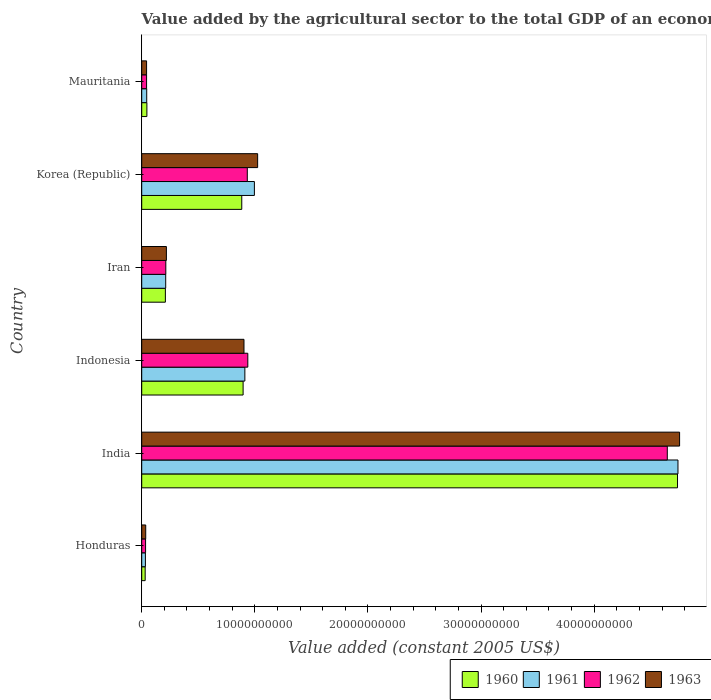How many different coloured bars are there?
Keep it short and to the point. 4. How many groups of bars are there?
Your answer should be very brief. 6. Are the number of bars per tick equal to the number of legend labels?
Offer a terse response. Yes. Are the number of bars on each tick of the Y-axis equal?
Your answer should be very brief. Yes. What is the label of the 1st group of bars from the top?
Your answer should be compact. Mauritania. What is the value added by the agricultural sector in 1961 in India?
Give a very brief answer. 4.74e+1. Across all countries, what is the maximum value added by the agricultural sector in 1963?
Make the answer very short. 4.76e+1. Across all countries, what is the minimum value added by the agricultural sector in 1961?
Offer a very short reply. 3.25e+08. In which country was the value added by the agricultural sector in 1960 minimum?
Provide a short and direct response. Honduras. What is the total value added by the agricultural sector in 1960 in the graph?
Give a very brief answer. 6.80e+1. What is the difference between the value added by the agricultural sector in 1963 in Iran and that in Mauritania?
Your response must be concise. 1.75e+09. What is the difference between the value added by the agricultural sector in 1960 in India and the value added by the agricultural sector in 1961 in Iran?
Your answer should be very brief. 4.52e+1. What is the average value added by the agricultural sector in 1963 per country?
Make the answer very short. 1.16e+1. What is the difference between the value added by the agricultural sector in 1963 and value added by the agricultural sector in 1962 in Indonesia?
Your response must be concise. -3.39e+08. What is the ratio of the value added by the agricultural sector in 1962 in Honduras to that in Korea (Republic)?
Offer a terse response. 0.04. Is the value added by the agricultural sector in 1963 in Indonesia less than that in Mauritania?
Make the answer very short. No. What is the difference between the highest and the second highest value added by the agricultural sector in 1961?
Offer a very short reply. 3.74e+1. What is the difference between the highest and the lowest value added by the agricultural sector in 1962?
Your answer should be compact. 4.61e+1. Is the sum of the value added by the agricultural sector in 1962 in Korea (Republic) and Mauritania greater than the maximum value added by the agricultural sector in 1963 across all countries?
Make the answer very short. No. Is it the case that in every country, the sum of the value added by the agricultural sector in 1961 and value added by the agricultural sector in 1962 is greater than the sum of value added by the agricultural sector in 1963 and value added by the agricultural sector in 1960?
Ensure brevity in your answer.  No. What does the 3rd bar from the top in Honduras represents?
Your response must be concise. 1961. How many bars are there?
Offer a very short reply. 24. Does the graph contain grids?
Your answer should be very brief. No. What is the title of the graph?
Your response must be concise. Value added by the agricultural sector to the total GDP of an economy. What is the label or title of the X-axis?
Your response must be concise. Value added (constant 2005 US$). What is the Value added (constant 2005 US$) in 1960 in Honduras?
Make the answer very short. 3.05e+08. What is the Value added (constant 2005 US$) of 1961 in Honduras?
Your response must be concise. 3.25e+08. What is the Value added (constant 2005 US$) of 1962 in Honduras?
Your answer should be compact. 3.41e+08. What is the Value added (constant 2005 US$) of 1963 in Honduras?
Your answer should be compact. 3.53e+08. What is the Value added (constant 2005 US$) of 1960 in India?
Provide a succinct answer. 4.74e+1. What is the Value added (constant 2005 US$) of 1961 in India?
Offer a very short reply. 4.74e+1. What is the Value added (constant 2005 US$) of 1962 in India?
Ensure brevity in your answer.  4.65e+1. What is the Value added (constant 2005 US$) in 1963 in India?
Ensure brevity in your answer.  4.76e+1. What is the Value added (constant 2005 US$) in 1960 in Indonesia?
Ensure brevity in your answer.  8.96e+09. What is the Value added (constant 2005 US$) of 1961 in Indonesia?
Your answer should be very brief. 9.12e+09. What is the Value added (constant 2005 US$) in 1962 in Indonesia?
Offer a very short reply. 9.38e+09. What is the Value added (constant 2005 US$) in 1963 in Indonesia?
Make the answer very short. 9.04e+09. What is the Value added (constant 2005 US$) in 1960 in Iran?
Ensure brevity in your answer.  2.09e+09. What is the Value added (constant 2005 US$) in 1961 in Iran?
Offer a very short reply. 2.12e+09. What is the Value added (constant 2005 US$) of 1962 in Iran?
Keep it short and to the point. 2.13e+09. What is the Value added (constant 2005 US$) in 1963 in Iran?
Provide a succinct answer. 2.18e+09. What is the Value added (constant 2005 US$) of 1960 in Korea (Republic)?
Keep it short and to the point. 8.84e+09. What is the Value added (constant 2005 US$) of 1961 in Korea (Republic)?
Offer a terse response. 9.96e+09. What is the Value added (constant 2005 US$) of 1962 in Korea (Republic)?
Give a very brief answer. 9.33e+09. What is the Value added (constant 2005 US$) in 1963 in Korea (Republic)?
Make the answer very short. 1.02e+1. What is the Value added (constant 2005 US$) of 1960 in Mauritania?
Provide a short and direct response. 4.57e+08. What is the Value added (constant 2005 US$) in 1961 in Mauritania?
Offer a very short reply. 4.42e+08. What is the Value added (constant 2005 US$) of 1962 in Mauritania?
Make the answer very short. 4.29e+08. What is the Value added (constant 2005 US$) of 1963 in Mauritania?
Offer a terse response. 4.30e+08. Across all countries, what is the maximum Value added (constant 2005 US$) in 1960?
Your response must be concise. 4.74e+1. Across all countries, what is the maximum Value added (constant 2005 US$) in 1961?
Offer a very short reply. 4.74e+1. Across all countries, what is the maximum Value added (constant 2005 US$) of 1962?
Provide a short and direct response. 4.65e+1. Across all countries, what is the maximum Value added (constant 2005 US$) in 1963?
Your answer should be compact. 4.76e+1. Across all countries, what is the minimum Value added (constant 2005 US$) in 1960?
Provide a short and direct response. 3.05e+08. Across all countries, what is the minimum Value added (constant 2005 US$) of 1961?
Offer a terse response. 3.25e+08. Across all countries, what is the minimum Value added (constant 2005 US$) in 1962?
Provide a succinct answer. 3.41e+08. Across all countries, what is the minimum Value added (constant 2005 US$) of 1963?
Give a very brief answer. 3.53e+08. What is the total Value added (constant 2005 US$) in 1960 in the graph?
Offer a very short reply. 6.80e+1. What is the total Value added (constant 2005 US$) in 1961 in the graph?
Offer a very short reply. 6.94e+1. What is the total Value added (constant 2005 US$) of 1962 in the graph?
Offer a terse response. 6.81e+1. What is the total Value added (constant 2005 US$) of 1963 in the graph?
Keep it short and to the point. 6.98e+1. What is the difference between the Value added (constant 2005 US$) of 1960 in Honduras and that in India?
Make the answer very short. -4.71e+1. What is the difference between the Value added (constant 2005 US$) in 1961 in Honduras and that in India?
Offer a terse response. -4.71e+1. What is the difference between the Value added (constant 2005 US$) of 1962 in Honduras and that in India?
Give a very brief answer. -4.61e+1. What is the difference between the Value added (constant 2005 US$) in 1963 in Honduras and that in India?
Provide a short and direct response. -4.72e+1. What is the difference between the Value added (constant 2005 US$) of 1960 in Honduras and that in Indonesia?
Give a very brief answer. -8.66e+09. What is the difference between the Value added (constant 2005 US$) in 1961 in Honduras and that in Indonesia?
Ensure brevity in your answer.  -8.79e+09. What is the difference between the Value added (constant 2005 US$) in 1962 in Honduras and that in Indonesia?
Your answer should be very brief. -9.04e+09. What is the difference between the Value added (constant 2005 US$) in 1963 in Honduras and that in Indonesia?
Offer a very short reply. -8.69e+09. What is the difference between the Value added (constant 2005 US$) in 1960 in Honduras and that in Iran?
Provide a short and direct response. -1.79e+09. What is the difference between the Value added (constant 2005 US$) of 1961 in Honduras and that in Iran?
Your answer should be compact. -1.79e+09. What is the difference between the Value added (constant 2005 US$) of 1962 in Honduras and that in Iran?
Your answer should be compact. -1.79e+09. What is the difference between the Value added (constant 2005 US$) of 1963 in Honduras and that in Iran?
Offer a very short reply. -1.83e+09. What is the difference between the Value added (constant 2005 US$) of 1960 in Honduras and that in Korea (Republic)?
Your answer should be compact. -8.54e+09. What is the difference between the Value added (constant 2005 US$) of 1961 in Honduras and that in Korea (Republic)?
Your answer should be compact. -9.64e+09. What is the difference between the Value added (constant 2005 US$) of 1962 in Honduras and that in Korea (Republic)?
Keep it short and to the point. -8.99e+09. What is the difference between the Value added (constant 2005 US$) in 1963 in Honduras and that in Korea (Republic)?
Ensure brevity in your answer.  -9.89e+09. What is the difference between the Value added (constant 2005 US$) in 1960 in Honduras and that in Mauritania?
Ensure brevity in your answer.  -1.51e+08. What is the difference between the Value added (constant 2005 US$) in 1961 in Honduras and that in Mauritania?
Offer a terse response. -1.17e+08. What is the difference between the Value added (constant 2005 US$) of 1962 in Honduras and that in Mauritania?
Your answer should be very brief. -8.84e+07. What is the difference between the Value added (constant 2005 US$) in 1963 in Honduras and that in Mauritania?
Your answer should be very brief. -7.67e+07. What is the difference between the Value added (constant 2005 US$) of 1960 in India and that in Indonesia?
Keep it short and to the point. 3.84e+1. What is the difference between the Value added (constant 2005 US$) in 1961 in India and that in Indonesia?
Your answer should be very brief. 3.83e+1. What is the difference between the Value added (constant 2005 US$) in 1962 in India and that in Indonesia?
Offer a very short reply. 3.71e+1. What is the difference between the Value added (constant 2005 US$) of 1963 in India and that in Indonesia?
Make the answer very short. 3.85e+1. What is the difference between the Value added (constant 2005 US$) of 1960 in India and that in Iran?
Your answer should be compact. 4.53e+1. What is the difference between the Value added (constant 2005 US$) of 1961 in India and that in Iran?
Keep it short and to the point. 4.53e+1. What is the difference between the Value added (constant 2005 US$) in 1962 in India and that in Iran?
Offer a terse response. 4.43e+1. What is the difference between the Value added (constant 2005 US$) in 1963 in India and that in Iran?
Give a very brief answer. 4.54e+1. What is the difference between the Value added (constant 2005 US$) of 1960 in India and that in Korea (Republic)?
Provide a short and direct response. 3.85e+1. What is the difference between the Value added (constant 2005 US$) of 1961 in India and that in Korea (Republic)?
Make the answer very short. 3.74e+1. What is the difference between the Value added (constant 2005 US$) in 1962 in India and that in Korea (Republic)?
Ensure brevity in your answer.  3.71e+1. What is the difference between the Value added (constant 2005 US$) of 1963 in India and that in Korea (Republic)?
Offer a very short reply. 3.73e+1. What is the difference between the Value added (constant 2005 US$) of 1960 in India and that in Mauritania?
Your response must be concise. 4.69e+1. What is the difference between the Value added (constant 2005 US$) of 1961 in India and that in Mauritania?
Your answer should be very brief. 4.70e+1. What is the difference between the Value added (constant 2005 US$) of 1962 in India and that in Mauritania?
Your answer should be compact. 4.60e+1. What is the difference between the Value added (constant 2005 US$) of 1963 in India and that in Mauritania?
Provide a short and direct response. 4.71e+1. What is the difference between the Value added (constant 2005 US$) in 1960 in Indonesia and that in Iran?
Your response must be concise. 6.87e+09. What is the difference between the Value added (constant 2005 US$) of 1961 in Indonesia and that in Iran?
Offer a terse response. 7.00e+09. What is the difference between the Value added (constant 2005 US$) of 1962 in Indonesia and that in Iran?
Ensure brevity in your answer.  7.25e+09. What is the difference between the Value added (constant 2005 US$) in 1963 in Indonesia and that in Iran?
Your answer should be very brief. 6.86e+09. What is the difference between the Value added (constant 2005 US$) in 1960 in Indonesia and that in Korea (Republic)?
Provide a succinct answer. 1.19e+08. What is the difference between the Value added (constant 2005 US$) of 1961 in Indonesia and that in Korea (Republic)?
Your answer should be very brief. -8.44e+08. What is the difference between the Value added (constant 2005 US$) in 1962 in Indonesia and that in Korea (Republic)?
Your response must be concise. 4.52e+07. What is the difference between the Value added (constant 2005 US$) of 1963 in Indonesia and that in Korea (Republic)?
Your response must be concise. -1.21e+09. What is the difference between the Value added (constant 2005 US$) of 1960 in Indonesia and that in Mauritania?
Your answer should be very brief. 8.51e+09. What is the difference between the Value added (constant 2005 US$) of 1961 in Indonesia and that in Mauritania?
Offer a very short reply. 8.68e+09. What is the difference between the Value added (constant 2005 US$) of 1962 in Indonesia and that in Mauritania?
Your response must be concise. 8.95e+09. What is the difference between the Value added (constant 2005 US$) in 1963 in Indonesia and that in Mauritania?
Your answer should be compact. 8.61e+09. What is the difference between the Value added (constant 2005 US$) of 1960 in Iran and that in Korea (Republic)?
Make the answer very short. -6.75e+09. What is the difference between the Value added (constant 2005 US$) in 1961 in Iran and that in Korea (Republic)?
Provide a succinct answer. -7.84e+09. What is the difference between the Value added (constant 2005 US$) in 1962 in Iran and that in Korea (Republic)?
Provide a succinct answer. -7.20e+09. What is the difference between the Value added (constant 2005 US$) of 1963 in Iran and that in Korea (Republic)?
Keep it short and to the point. -8.07e+09. What is the difference between the Value added (constant 2005 US$) in 1960 in Iran and that in Mauritania?
Make the answer very short. 1.63e+09. What is the difference between the Value added (constant 2005 US$) in 1961 in Iran and that in Mauritania?
Ensure brevity in your answer.  1.68e+09. What is the difference between the Value added (constant 2005 US$) of 1962 in Iran and that in Mauritania?
Ensure brevity in your answer.  1.70e+09. What is the difference between the Value added (constant 2005 US$) in 1963 in Iran and that in Mauritania?
Keep it short and to the point. 1.75e+09. What is the difference between the Value added (constant 2005 US$) of 1960 in Korea (Republic) and that in Mauritania?
Provide a succinct answer. 8.39e+09. What is the difference between the Value added (constant 2005 US$) of 1961 in Korea (Republic) and that in Mauritania?
Provide a short and direct response. 9.52e+09. What is the difference between the Value added (constant 2005 US$) in 1962 in Korea (Republic) and that in Mauritania?
Offer a terse response. 8.91e+09. What is the difference between the Value added (constant 2005 US$) of 1963 in Korea (Republic) and that in Mauritania?
Give a very brief answer. 9.82e+09. What is the difference between the Value added (constant 2005 US$) in 1960 in Honduras and the Value added (constant 2005 US$) in 1961 in India?
Offer a very short reply. -4.71e+1. What is the difference between the Value added (constant 2005 US$) in 1960 in Honduras and the Value added (constant 2005 US$) in 1962 in India?
Your answer should be compact. -4.62e+1. What is the difference between the Value added (constant 2005 US$) of 1960 in Honduras and the Value added (constant 2005 US$) of 1963 in India?
Your response must be concise. -4.72e+1. What is the difference between the Value added (constant 2005 US$) of 1961 in Honduras and the Value added (constant 2005 US$) of 1962 in India?
Give a very brief answer. -4.61e+1. What is the difference between the Value added (constant 2005 US$) in 1961 in Honduras and the Value added (constant 2005 US$) in 1963 in India?
Offer a very short reply. -4.72e+1. What is the difference between the Value added (constant 2005 US$) of 1962 in Honduras and the Value added (constant 2005 US$) of 1963 in India?
Your answer should be very brief. -4.72e+1. What is the difference between the Value added (constant 2005 US$) of 1960 in Honduras and the Value added (constant 2005 US$) of 1961 in Indonesia?
Your answer should be very brief. -8.81e+09. What is the difference between the Value added (constant 2005 US$) of 1960 in Honduras and the Value added (constant 2005 US$) of 1962 in Indonesia?
Your answer should be compact. -9.07e+09. What is the difference between the Value added (constant 2005 US$) of 1960 in Honduras and the Value added (constant 2005 US$) of 1963 in Indonesia?
Provide a short and direct response. -8.73e+09. What is the difference between the Value added (constant 2005 US$) of 1961 in Honduras and the Value added (constant 2005 US$) of 1962 in Indonesia?
Offer a terse response. -9.05e+09. What is the difference between the Value added (constant 2005 US$) of 1961 in Honduras and the Value added (constant 2005 US$) of 1963 in Indonesia?
Ensure brevity in your answer.  -8.72e+09. What is the difference between the Value added (constant 2005 US$) of 1962 in Honduras and the Value added (constant 2005 US$) of 1963 in Indonesia?
Make the answer very short. -8.70e+09. What is the difference between the Value added (constant 2005 US$) of 1960 in Honduras and the Value added (constant 2005 US$) of 1961 in Iran?
Offer a terse response. -1.81e+09. What is the difference between the Value added (constant 2005 US$) in 1960 in Honduras and the Value added (constant 2005 US$) in 1962 in Iran?
Ensure brevity in your answer.  -1.82e+09. What is the difference between the Value added (constant 2005 US$) of 1960 in Honduras and the Value added (constant 2005 US$) of 1963 in Iran?
Ensure brevity in your answer.  -1.88e+09. What is the difference between the Value added (constant 2005 US$) in 1961 in Honduras and the Value added (constant 2005 US$) in 1962 in Iran?
Offer a terse response. -1.80e+09. What is the difference between the Value added (constant 2005 US$) of 1961 in Honduras and the Value added (constant 2005 US$) of 1963 in Iran?
Give a very brief answer. -1.86e+09. What is the difference between the Value added (constant 2005 US$) of 1962 in Honduras and the Value added (constant 2005 US$) of 1963 in Iran?
Provide a succinct answer. -1.84e+09. What is the difference between the Value added (constant 2005 US$) in 1960 in Honduras and the Value added (constant 2005 US$) in 1961 in Korea (Republic)?
Offer a terse response. -9.66e+09. What is the difference between the Value added (constant 2005 US$) of 1960 in Honduras and the Value added (constant 2005 US$) of 1962 in Korea (Republic)?
Provide a short and direct response. -9.03e+09. What is the difference between the Value added (constant 2005 US$) in 1960 in Honduras and the Value added (constant 2005 US$) in 1963 in Korea (Republic)?
Provide a short and direct response. -9.94e+09. What is the difference between the Value added (constant 2005 US$) of 1961 in Honduras and the Value added (constant 2005 US$) of 1962 in Korea (Republic)?
Your response must be concise. -9.01e+09. What is the difference between the Value added (constant 2005 US$) of 1961 in Honduras and the Value added (constant 2005 US$) of 1963 in Korea (Republic)?
Make the answer very short. -9.92e+09. What is the difference between the Value added (constant 2005 US$) of 1962 in Honduras and the Value added (constant 2005 US$) of 1963 in Korea (Republic)?
Provide a short and direct response. -9.91e+09. What is the difference between the Value added (constant 2005 US$) in 1960 in Honduras and the Value added (constant 2005 US$) in 1961 in Mauritania?
Make the answer very short. -1.37e+08. What is the difference between the Value added (constant 2005 US$) in 1960 in Honduras and the Value added (constant 2005 US$) in 1962 in Mauritania?
Provide a succinct answer. -1.24e+08. What is the difference between the Value added (constant 2005 US$) of 1960 in Honduras and the Value added (constant 2005 US$) of 1963 in Mauritania?
Make the answer very short. -1.24e+08. What is the difference between the Value added (constant 2005 US$) of 1961 in Honduras and the Value added (constant 2005 US$) of 1962 in Mauritania?
Keep it short and to the point. -1.04e+08. What is the difference between the Value added (constant 2005 US$) of 1961 in Honduras and the Value added (constant 2005 US$) of 1963 in Mauritania?
Give a very brief answer. -1.05e+08. What is the difference between the Value added (constant 2005 US$) of 1962 in Honduras and the Value added (constant 2005 US$) of 1963 in Mauritania?
Provide a succinct answer. -8.91e+07. What is the difference between the Value added (constant 2005 US$) in 1960 in India and the Value added (constant 2005 US$) in 1961 in Indonesia?
Make the answer very short. 3.83e+1. What is the difference between the Value added (constant 2005 US$) in 1960 in India and the Value added (constant 2005 US$) in 1962 in Indonesia?
Your response must be concise. 3.80e+1. What is the difference between the Value added (constant 2005 US$) in 1960 in India and the Value added (constant 2005 US$) in 1963 in Indonesia?
Provide a succinct answer. 3.83e+1. What is the difference between the Value added (constant 2005 US$) of 1961 in India and the Value added (constant 2005 US$) of 1962 in Indonesia?
Your answer should be very brief. 3.80e+1. What is the difference between the Value added (constant 2005 US$) of 1961 in India and the Value added (constant 2005 US$) of 1963 in Indonesia?
Provide a succinct answer. 3.84e+1. What is the difference between the Value added (constant 2005 US$) in 1962 in India and the Value added (constant 2005 US$) in 1963 in Indonesia?
Offer a very short reply. 3.74e+1. What is the difference between the Value added (constant 2005 US$) of 1960 in India and the Value added (constant 2005 US$) of 1961 in Iran?
Offer a very short reply. 4.52e+1. What is the difference between the Value added (constant 2005 US$) in 1960 in India and the Value added (constant 2005 US$) in 1962 in Iran?
Give a very brief answer. 4.52e+1. What is the difference between the Value added (constant 2005 US$) of 1960 in India and the Value added (constant 2005 US$) of 1963 in Iran?
Keep it short and to the point. 4.52e+1. What is the difference between the Value added (constant 2005 US$) of 1961 in India and the Value added (constant 2005 US$) of 1962 in Iran?
Provide a succinct answer. 4.53e+1. What is the difference between the Value added (constant 2005 US$) in 1961 in India and the Value added (constant 2005 US$) in 1963 in Iran?
Offer a very short reply. 4.52e+1. What is the difference between the Value added (constant 2005 US$) in 1962 in India and the Value added (constant 2005 US$) in 1963 in Iran?
Ensure brevity in your answer.  4.43e+1. What is the difference between the Value added (constant 2005 US$) of 1960 in India and the Value added (constant 2005 US$) of 1961 in Korea (Republic)?
Keep it short and to the point. 3.74e+1. What is the difference between the Value added (constant 2005 US$) of 1960 in India and the Value added (constant 2005 US$) of 1962 in Korea (Republic)?
Your response must be concise. 3.80e+1. What is the difference between the Value added (constant 2005 US$) of 1960 in India and the Value added (constant 2005 US$) of 1963 in Korea (Republic)?
Ensure brevity in your answer.  3.71e+1. What is the difference between the Value added (constant 2005 US$) in 1961 in India and the Value added (constant 2005 US$) in 1962 in Korea (Republic)?
Give a very brief answer. 3.81e+1. What is the difference between the Value added (constant 2005 US$) of 1961 in India and the Value added (constant 2005 US$) of 1963 in Korea (Republic)?
Offer a very short reply. 3.72e+1. What is the difference between the Value added (constant 2005 US$) in 1962 in India and the Value added (constant 2005 US$) in 1963 in Korea (Republic)?
Offer a terse response. 3.62e+1. What is the difference between the Value added (constant 2005 US$) in 1960 in India and the Value added (constant 2005 US$) in 1961 in Mauritania?
Your answer should be very brief. 4.69e+1. What is the difference between the Value added (constant 2005 US$) in 1960 in India and the Value added (constant 2005 US$) in 1962 in Mauritania?
Your answer should be compact. 4.69e+1. What is the difference between the Value added (constant 2005 US$) in 1960 in India and the Value added (constant 2005 US$) in 1963 in Mauritania?
Your answer should be very brief. 4.69e+1. What is the difference between the Value added (constant 2005 US$) in 1961 in India and the Value added (constant 2005 US$) in 1962 in Mauritania?
Make the answer very short. 4.70e+1. What is the difference between the Value added (constant 2005 US$) in 1961 in India and the Value added (constant 2005 US$) in 1963 in Mauritania?
Keep it short and to the point. 4.70e+1. What is the difference between the Value added (constant 2005 US$) in 1962 in India and the Value added (constant 2005 US$) in 1963 in Mauritania?
Your response must be concise. 4.60e+1. What is the difference between the Value added (constant 2005 US$) in 1960 in Indonesia and the Value added (constant 2005 US$) in 1961 in Iran?
Your answer should be compact. 6.84e+09. What is the difference between the Value added (constant 2005 US$) in 1960 in Indonesia and the Value added (constant 2005 US$) in 1962 in Iran?
Offer a very short reply. 6.83e+09. What is the difference between the Value added (constant 2005 US$) in 1960 in Indonesia and the Value added (constant 2005 US$) in 1963 in Iran?
Offer a terse response. 6.78e+09. What is the difference between the Value added (constant 2005 US$) of 1961 in Indonesia and the Value added (constant 2005 US$) of 1962 in Iran?
Provide a succinct answer. 6.99e+09. What is the difference between the Value added (constant 2005 US$) of 1961 in Indonesia and the Value added (constant 2005 US$) of 1963 in Iran?
Offer a terse response. 6.94e+09. What is the difference between the Value added (constant 2005 US$) in 1962 in Indonesia and the Value added (constant 2005 US$) in 1963 in Iran?
Provide a succinct answer. 7.20e+09. What is the difference between the Value added (constant 2005 US$) in 1960 in Indonesia and the Value added (constant 2005 US$) in 1961 in Korea (Republic)?
Your answer should be very brief. -9.98e+08. What is the difference between the Value added (constant 2005 US$) of 1960 in Indonesia and the Value added (constant 2005 US$) of 1962 in Korea (Republic)?
Your response must be concise. -3.71e+08. What is the difference between the Value added (constant 2005 US$) of 1960 in Indonesia and the Value added (constant 2005 US$) of 1963 in Korea (Republic)?
Keep it short and to the point. -1.28e+09. What is the difference between the Value added (constant 2005 US$) in 1961 in Indonesia and the Value added (constant 2005 US$) in 1962 in Korea (Republic)?
Your answer should be very brief. -2.17e+08. What is the difference between the Value added (constant 2005 US$) of 1961 in Indonesia and the Value added (constant 2005 US$) of 1963 in Korea (Republic)?
Make the answer very short. -1.13e+09. What is the difference between the Value added (constant 2005 US$) of 1962 in Indonesia and the Value added (constant 2005 US$) of 1963 in Korea (Republic)?
Your response must be concise. -8.69e+08. What is the difference between the Value added (constant 2005 US$) in 1960 in Indonesia and the Value added (constant 2005 US$) in 1961 in Mauritania?
Keep it short and to the point. 8.52e+09. What is the difference between the Value added (constant 2005 US$) of 1960 in Indonesia and the Value added (constant 2005 US$) of 1962 in Mauritania?
Ensure brevity in your answer.  8.53e+09. What is the difference between the Value added (constant 2005 US$) of 1960 in Indonesia and the Value added (constant 2005 US$) of 1963 in Mauritania?
Offer a very short reply. 8.53e+09. What is the difference between the Value added (constant 2005 US$) in 1961 in Indonesia and the Value added (constant 2005 US$) in 1962 in Mauritania?
Your answer should be very brief. 8.69e+09. What is the difference between the Value added (constant 2005 US$) in 1961 in Indonesia and the Value added (constant 2005 US$) in 1963 in Mauritania?
Your answer should be very brief. 8.69e+09. What is the difference between the Value added (constant 2005 US$) in 1962 in Indonesia and the Value added (constant 2005 US$) in 1963 in Mauritania?
Your answer should be very brief. 8.95e+09. What is the difference between the Value added (constant 2005 US$) of 1960 in Iran and the Value added (constant 2005 US$) of 1961 in Korea (Republic)?
Provide a short and direct response. -7.87e+09. What is the difference between the Value added (constant 2005 US$) in 1960 in Iran and the Value added (constant 2005 US$) in 1962 in Korea (Republic)?
Make the answer very short. -7.24e+09. What is the difference between the Value added (constant 2005 US$) in 1960 in Iran and the Value added (constant 2005 US$) in 1963 in Korea (Republic)?
Your response must be concise. -8.16e+09. What is the difference between the Value added (constant 2005 US$) in 1961 in Iran and the Value added (constant 2005 US$) in 1962 in Korea (Republic)?
Provide a succinct answer. -7.21e+09. What is the difference between the Value added (constant 2005 US$) in 1961 in Iran and the Value added (constant 2005 US$) in 1963 in Korea (Republic)?
Offer a very short reply. -8.13e+09. What is the difference between the Value added (constant 2005 US$) of 1962 in Iran and the Value added (constant 2005 US$) of 1963 in Korea (Republic)?
Your answer should be compact. -8.12e+09. What is the difference between the Value added (constant 2005 US$) in 1960 in Iran and the Value added (constant 2005 US$) in 1961 in Mauritania?
Ensure brevity in your answer.  1.65e+09. What is the difference between the Value added (constant 2005 US$) in 1960 in Iran and the Value added (constant 2005 US$) in 1962 in Mauritania?
Keep it short and to the point. 1.66e+09. What is the difference between the Value added (constant 2005 US$) in 1960 in Iran and the Value added (constant 2005 US$) in 1963 in Mauritania?
Provide a short and direct response. 1.66e+09. What is the difference between the Value added (constant 2005 US$) of 1961 in Iran and the Value added (constant 2005 US$) of 1962 in Mauritania?
Offer a very short reply. 1.69e+09. What is the difference between the Value added (constant 2005 US$) in 1961 in Iran and the Value added (constant 2005 US$) in 1963 in Mauritania?
Offer a very short reply. 1.69e+09. What is the difference between the Value added (constant 2005 US$) in 1962 in Iran and the Value added (constant 2005 US$) in 1963 in Mauritania?
Give a very brief answer. 1.70e+09. What is the difference between the Value added (constant 2005 US$) of 1960 in Korea (Republic) and the Value added (constant 2005 US$) of 1961 in Mauritania?
Make the answer very short. 8.40e+09. What is the difference between the Value added (constant 2005 US$) in 1960 in Korea (Republic) and the Value added (constant 2005 US$) in 1962 in Mauritania?
Ensure brevity in your answer.  8.41e+09. What is the difference between the Value added (constant 2005 US$) in 1960 in Korea (Republic) and the Value added (constant 2005 US$) in 1963 in Mauritania?
Offer a terse response. 8.41e+09. What is the difference between the Value added (constant 2005 US$) in 1961 in Korea (Republic) and the Value added (constant 2005 US$) in 1962 in Mauritania?
Keep it short and to the point. 9.53e+09. What is the difference between the Value added (constant 2005 US$) of 1961 in Korea (Republic) and the Value added (constant 2005 US$) of 1963 in Mauritania?
Your answer should be compact. 9.53e+09. What is the difference between the Value added (constant 2005 US$) in 1962 in Korea (Republic) and the Value added (constant 2005 US$) in 1963 in Mauritania?
Provide a succinct answer. 8.90e+09. What is the average Value added (constant 2005 US$) in 1960 per country?
Make the answer very short. 1.13e+1. What is the average Value added (constant 2005 US$) in 1961 per country?
Make the answer very short. 1.16e+1. What is the average Value added (constant 2005 US$) in 1962 per country?
Make the answer very short. 1.13e+1. What is the average Value added (constant 2005 US$) in 1963 per country?
Your response must be concise. 1.16e+1. What is the difference between the Value added (constant 2005 US$) in 1960 and Value added (constant 2005 US$) in 1961 in Honduras?
Offer a very short reply. -1.99e+07. What is the difference between the Value added (constant 2005 US$) in 1960 and Value added (constant 2005 US$) in 1962 in Honduras?
Make the answer very short. -3.54e+07. What is the difference between the Value added (constant 2005 US$) of 1960 and Value added (constant 2005 US$) of 1963 in Honduras?
Your answer should be very brief. -4.78e+07. What is the difference between the Value added (constant 2005 US$) of 1961 and Value added (constant 2005 US$) of 1962 in Honduras?
Make the answer very short. -1.55e+07. What is the difference between the Value added (constant 2005 US$) of 1961 and Value added (constant 2005 US$) of 1963 in Honduras?
Offer a very short reply. -2.79e+07. What is the difference between the Value added (constant 2005 US$) in 1962 and Value added (constant 2005 US$) in 1963 in Honduras?
Provide a short and direct response. -1.24e+07. What is the difference between the Value added (constant 2005 US$) in 1960 and Value added (constant 2005 US$) in 1961 in India?
Make the answer very short. -3.99e+07. What is the difference between the Value added (constant 2005 US$) in 1960 and Value added (constant 2005 US$) in 1962 in India?
Make the answer very short. 9.03e+08. What is the difference between the Value added (constant 2005 US$) of 1960 and Value added (constant 2005 US$) of 1963 in India?
Your answer should be very brief. -1.84e+08. What is the difference between the Value added (constant 2005 US$) of 1961 and Value added (constant 2005 US$) of 1962 in India?
Keep it short and to the point. 9.43e+08. What is the difference between the Value added (constant 2005 US$) of 1961 and Value added (constant 2005 US$) of 1963 in India?
Offer a terse response. -1.44e+08. What is the difference between the Value added (constant 2005 US$) of 1962 and Value added (constant 2005 US$) of 1963 in India?
Keep it short and to the point. -1.09e+09. What is the difference between the Value added (constant 2005 US$) of 1960 and Value added (constant 2005 US$) of 1961 in Indonesia?
Provide a short and direct response. -1.54e+08. What is the difference between the Value added (constant 2005 US$) of 1960 and Value added (constant 2005 US$) of 1962 in Indonesia?
Offer a very short reply. -4.16e+08. What is the difference between the Value added (constant 2005 US$) of 1960 and Value added (constant 2005 US$) of 1963 in Indonesia?
Your answer should be very brief. -7.71e+07. What is the difference between the Value added (constant 2005 US$) in 1961 and Value added (constant 2005 US$) in 1962 in Indonesia?
Give a very brief answer. -2.62e+08. What is the difference between the Value added (constant 2005 US$) of 1961 and Value added (constant 2005 US$) of 1963 in Indonesia?
Give a very brief answer. 7.71e+07. What is the difference between the Value added (constant 2005 US$) of 1962 and Value added (constant 2005 US$) of 1963 in Indonesia?
Ensure brevity in your answer.  3.39e+08. What is the difference between the Value added (constant 2005 US$) of 1960 and Value added (constant 2005 US$) of 1961 in Iran?
Make the answer very short. -2.84e+07. What is the difference between the Value added (constant 2005 US$) of 1960 and Value added (constant 2005 US$) of 1962 in Iran?
Give a very brief answer. -3.89e+07. What is the difference between the Value added (constant 2005 US$) in 1960 and Value added (constant 2005 US$) in 1963 in Iran?
Make the answer very short. -9.02e+07. What is the difference between the Value added (constant 2005 US$) of 1961 and Value added (constant 2005 US$) of 1962 in Iran?
Ensure brevity in your answer.  -1.05e+07. What is the difference between the Value added (constant 2005 US$) of 1961 and Value added (constant 2005 US$) of 1963 in Iran?
Your answer should be compact. -6.18e+07. What is the difference between the Value added (constant 2005 US$) in 1962 and Value added (constant 2005 US$) in 1963 in Iran?
Make the answer very short. -5.13e+07. What is the difference between the Value added (constant 2005 US$) in 1960 and Value added (constant 2005 US$) in 1961 in Korea (Republic)?
Make the answer very short. -1.12e+09. What is the difference between the Value added (constant 2005 US$) of 1960 and Value added (constant 2005 US$) of 1962 in Korea (Republic)?
Make the answer very short. -4.90e+08. What is the difference between the Value added (constant 2005 US$) in 1960 and Value added (constant 2005 US$) in 1963 in Korea (Republic)?
Give a very brief answer. -1.40e+09. What is the difference between the Value added (constant 2005 US$) in 1961 and Value added (constant 2005 US$) in 1962 in Korea (Republic)?
Your answer should be very brief. 6.27e+08. What is the difference between the Value added (constant 2005 US$) in 1961 and Value added (constant 2005 US$) in 1963 in Korea (Republic)?
Your answer should be compact. -2.87e+08. What is the difference between the Value added (constant 2005 US$) of 1962 and Value added (constant 2005 US$) of 1963 in Korea (Republic)?
Your answer should be compact. -9.14e+08. What is the difference between the Value added (constant 2005 US$) in 1960 and Value added (constant 2005 US$) in 1961 in Mauritania?
Your answer should be very brief. 1.44e+07. What is the difference between the Value added (constant 2005 US$) in 1960 and Value added (constant 2005 US$) in 1962 in Mauritania?
Your answer should be very brief. 2.75e+07. What is the difference between the Value added (constant 2005 US$) of 1960 and Value added (constant 2005 US$) of 1963 in Mauritania?
Your answer should be compact. 2.68e+07. What is the difference between the Value added (constant 2005 US$) of 1961 and Value added (constant 2005 US$) of 1962 in Mauritania?
Your answer should be compact. 1.31e+07. What is the difference between the Value added (constant 2005 US$) of 1961 and Value added (constant 2005 US$) of 1963 in Mauritania?
Offer a terse response. 1.24e+07. What is the difference between the Value added (constant 2005 US$) in 1962 and Value added (constant 2005 US$) in 1963 in Mauritania?
Ensure brevity in your answer.  -7.06e+05. What is the ratio of the Value added (constant 2005 US$) in 1960 in Honduras to that in India?
Offer a terse response. 0.01. What is the ratio of the Value added (constant 2005 US$) in 1961 in Honduras to that in India?
Your answer should be very brief. 0.01. What is the ratio of the Value added (constant 2005 US$) in 1962 in Honduras to that in India?
Give a very brief answer. 0.01. What is the ratio of the Value added (constant 2005 US$) of 1963 in Honduras to that in India?
Provide a short and direct response. 0.01. What is the ratio of the Value added (constant 2005 US$) in 1960 in Honduras to that in Indonesia?
Give a very brief answer. 0.03. What is the ratio of the Value added (constant 2005 US$) in 1961 in Honduras to that in Indonesia?
Make the answer very short. 0.04. What is the ratio of the Value added (constant 2005 US$) in 1962 in Honduras to that in Indonesia?
Offer a terse response. 0.04. What is the ratio of the Value added (constant 2005 US$) of 1963 in Honduras to that in Indonesia?
Give a very brief answer. 0.04. What is the ratio of the Value added (constant 2005 US$) in 1960 in Honduras to that in Iran?
Your response must be concise. 0.15. What is the ratio of the Value added (constant 2005 US$) of 1961 in Honduras to that in Iran?
Provide a short and direct response. 0.15. What is the ratio of the Value added (constant 2005 US$) of 1962 in Honduras to that in Iran?
Your answer should be very brief. 0.16. What is the ratio of the Value added (constant 2005 US$) of 1963 in Honduras to that in Iran?
Your response must be concise. 0.16. What is the ratio of the Value added (constant 2005 US$) in 1960 in Honduras to that in Korea (Republic)?
Your answer should be very brief. 0.03. What is the ratio of the Value added (constant 2005 US$) in 1961 in Honduras to that in Korea (Republic)?
Provide a succinct answer. 0.03. What is the ratio of the Value added (constant 2005 US$) of 1962 in Honduras to that in Korea (Republic)?
Keep it short and to the point. 0.04. What is the ratio of the Value added (constant 2005 US$) of 1963 in Honduras to that in Korea (Republic)?
Provide a short and direct response. 0.03. What is the ratio of the Value added (constant 2005 US$) of 1960 in Honduras to that in Mauritania?
Keep it short and to the point. 0.67. What is the ratio of the Value added (constant 2005 US$) in 1961 in Honduras to that in Mauritania?
Provide a short and direct response. 0.74. What is the ratio of the Value added (constant 2005 US$) of 1962 in Honduras to that in Mauritania?
Your response must be concise. 0.79. What is the ratio of the Value added (constant 2005 US$) of 1963 in Honduras to that in Mauritania?
Your response must be concise. 0.82. What is the ratio of the Value added (constant 2005 US$) in 1960 in India to that in Indonesia?
Keep it short and to the point. 5.28. What is the ratio of the Value added (constant 2005 US$) in 1961 in India to that in Indonesia?
Offer a very short reply. 5.2. What is the ratio of the Value added (constant 2005 US$) in 1962 in India to that in Indonesia?
Give a very brief answer. 4.95. What is the ratio of the Value added (constant 2005 US$) of 1963 in India to that in Indonesia?
Your answer should be compact. 5.26. What is the ratio of the Value added (constant 2005 US$) of 1960 in India to that in Iran?
Give a very brief answer. 22.65. What is the ratio of the Value added (constant 2005 US$) in 1961 in India to that in Iran?
Offer a very short reply. 22.37. What is the ratio of the Value added (constant 2005 US$) of 1962 in India to that in Iran?
Your answer should be very brief. 21.81. What is the ratio of the Value added (constant 2005 US$) of 1963 in India to that in Iran?
Your response must be concise. 21.8. What is the ratio of the Value added (constant 2005 US$) in 1960 in India to that in Korea (Republic)?
Your answer should be very brief. 5.36. What is the ratio of the Value added (constant 2005 US$) of 1961 in India to that in Korea (Republic)?
Your answer should be compact. 4.76. What is the ratio of the Value added (constant 2005 US$) in 1962 in India to that in Korea (Republic)?
Make the answer very short. 4.98. What is the ratio of the Value added (constant 2005 US$) in 1963 in India to that in Korea (Republic)?
Your answer should be compact. 4.64. What is the ratio of the Value added (constant 2005 US$) of 1960 in India to that in Mauritania?
Your response must be concise. 103.72. What is the ratio of the Value added (constant 2005 US$) in 1961 in India to that in Mauritania?
Ensure brevity in your answer.  107.19. What is the ratio of the Value added (constant 2005 US$) of 1962 in India to that in Mauritania?
Offer a very short reply. 108.27. What is the ratio of the Value added (constant 2005 US$) of 1963 in India to that in Mauritania?
Keep it short and to the point. 110.62. What is the ratio of the Value added (constant 2005 US$) of 1960 in Indonesia to that in Iran?
Your answer should be very brief. 4.29. What is the ratio of the Value added (constant 2005 US$) in 1961 in Indonesia to that in Iran?
Provide a short and direct response. 4.3. What is the ratio of the Value added (constant 2005 US$) of 1962 in Indonesia to that in Iran?
Provide a short and direct response. 4.4. What is the ratio of the Value added (constant 2005 US$) in 1963 in Indonesia to that in Iran?
Offer a very short reply. 4.14. What is the ratio of the Value added (constant 2005 US$) in 1960 in Indonesia to that in Korea (Republic)?
Keep it short and to the point. 1.01. What is the ratio of the Value added (constant 2005 US$) of 1961 in Indonesia to that in Korea (Republic)?
Give a very brief answer. 0.92. What is the ratio of the Value added (constant 2005 US$) of 1963 in Indonesia to that in Korea (Republic)?
Your response must be concise. 0.88. What is the ratio of the Value added (constant 2005 US$) of 1960 in Indonesia to that in Mauritania?
Give a very brief answer. 19.63. What is the ratio of the Value added (constant 2005 US$) of 1961 in Indonesia to that in Mauritania?
Keep it short and to the point. 20.62. What is the ratio of the Value added (constant 2005 US$) in 1962 in Indonesia to that in Mauritania?
Your answer should be very brief. 21.86. What is the ratio of the Value added (constant 2005 US$) of 1963 in Indonesia to that in Mauritania?
Provide a short and direct response. 21.03. What is the ratio of the Value added (constant 2005 US$) in 1960 in Iran to that in Korea (Republic)?
Ensure brevity in your answer.  0.24. What is the ratio of the Value added (constant 2005 US$) of 1961 in Iran to that in Korea (Republic)?
Provide a short and direct response. 0.21. What is the ratio of the Value added (constant 2005 US$) of 1962 in Iran to that in Korea (Republic)?
Your answer should be very brief. 0.23. What is the ratio of the Value added (constant 2005 US$) in 1963 in Iran to that in Korea (Republic)?
Offer a terse response. 0.21. What is the ratio of the Value added (constant 2005 US$) in 1960 in Iran to that in Mauritania?
Make the answer very short. 4.58. What is the ratio of the Value added (constant 2005 US$) of 1961 in Iran to that in Mauritania?
Your answer should be very brief. 4.79. What is the ratio of the Value added (constant 2005 US$) of 1962 in Iran to that in Mauritania?
Keep it short and to the point. 4.96. What is the ratio of the Value added (constant 2005 US$) in 1963 in Iran to that in Mauritania?
Ensure brevity in your answer.  5.07. What is the ratio of the Value added (constant 2005 US$) in 1960 in Korea (Republic) to that in Mauritania?
Provide a short and direct response. 19.37. What is the ratio of the Value added (constant 2005 US$) of 1961 in Korea (Republic) to that in Mauritania?
Your response must be concise. 22.52. What is the ratio of the Value added (constant 2005 US$) of 1962 in Korea (Republic) to that in Mauritania?
Your response must be concise. 21.75. What is the ratio of the Value added (constant 2005 US$) in 1963 in Korea (Republic) to that in Mauritania?
Keep it short and to the point. 23.84. What is the difference between the highest and the second highest Value added (constant 2005 US$) in 1960?
Offer a terse response. 3.84e+1. What is the difference between the highest and the second highest Value added (constant 2005 US$) of 1961?
Provide a succinct answer. 3.74e+1. What is the difference between the highest and the second highest Value added (constant 2005 US$) of 1962?
Give a very brief answer. 3.71e+1. What is the difference between the highest and the second highest Value added (constant 2005 US$) of 1963?
Offer a terse response. 3.73e+1. What is the difference between the highest and the lowest Value added (constant 2005 US$) in 1960?
Keep it short and to the point. 4.71e+1. What is the difference between the highest and the lowest Value added (constant 2005 US$) in 1961?
Your answer should be very brief. 4.71e+1. What is the difference between the highest and the lowest Value added (constant 2005 US$) in 1962?
Ensure brevity in your answer.  4.61e+1. What is the difference between the highest and the lowest Value added (constant 2005 US$) in 1963?
Provide a short and direct response. 4.72e+1. 